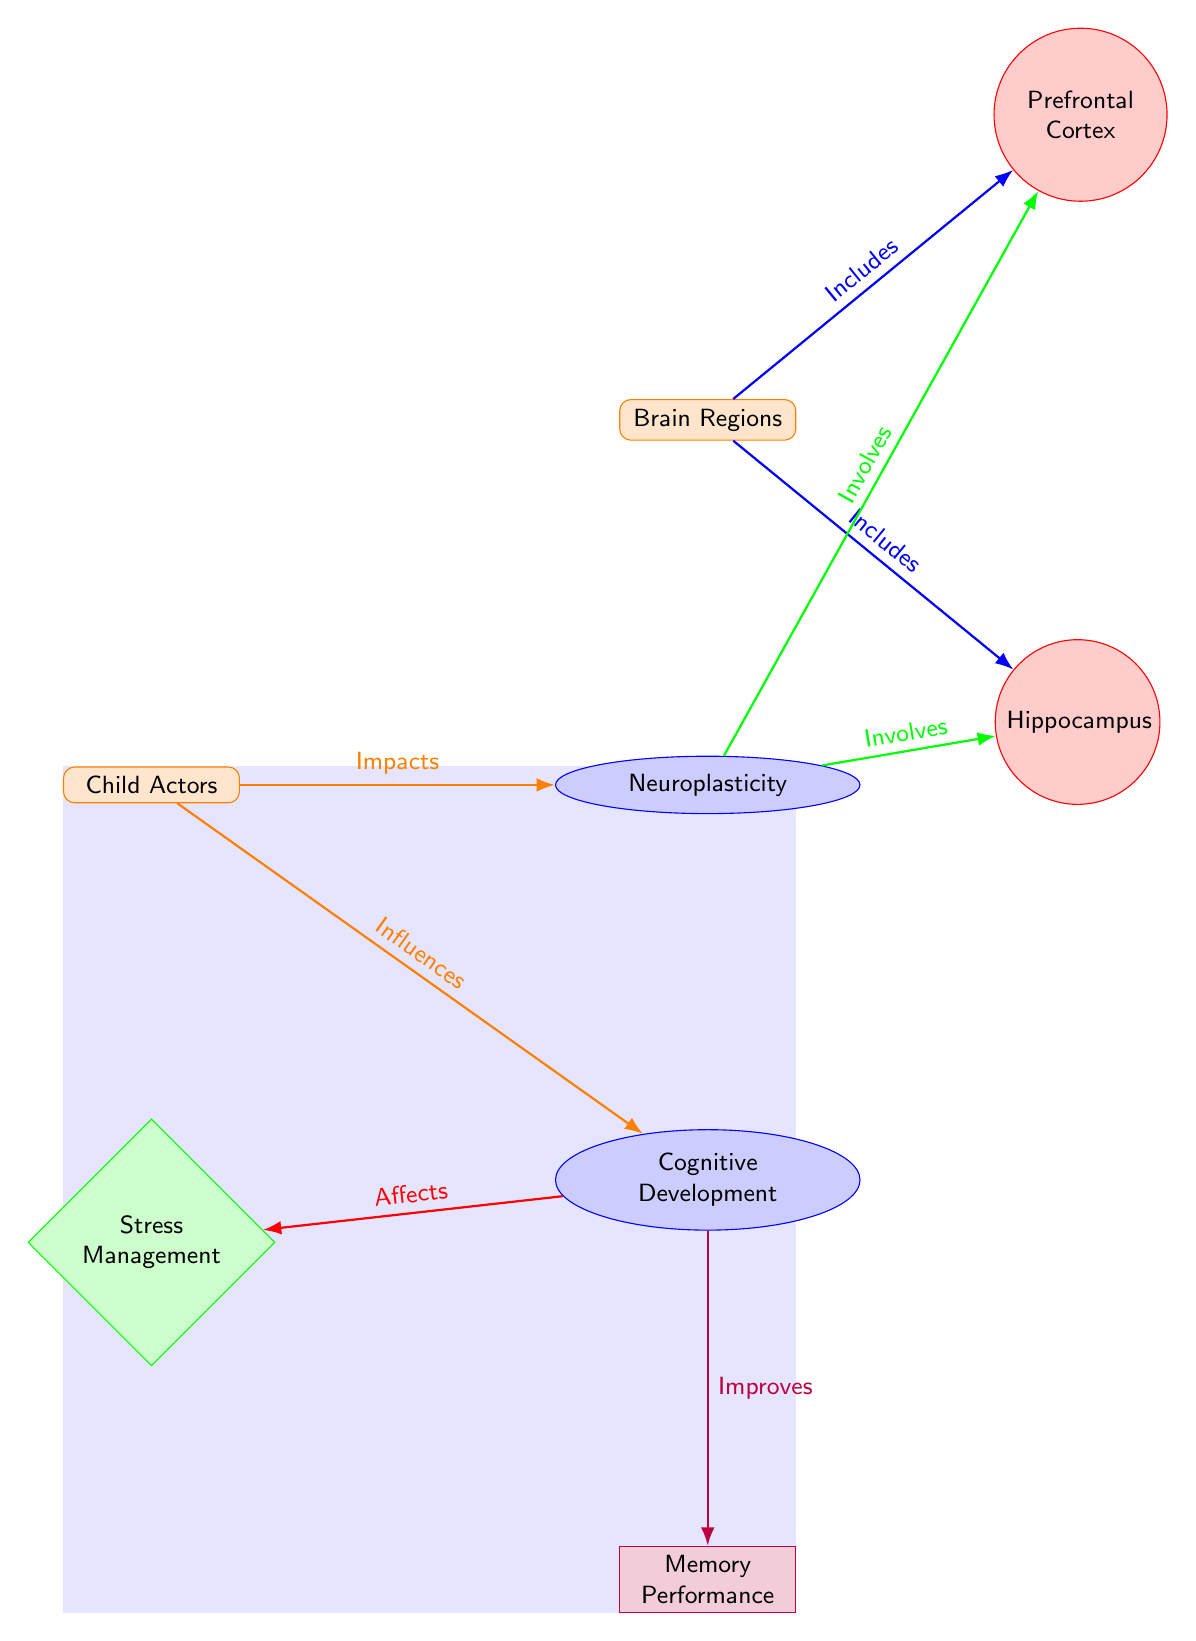What are the main categories depicted in the diagram? The diagram shows the categories "Child Actors" and "Brain Regions" as the two main categories at the top and bottom of the diagram.
Answer: Child Actors, Brain Regions How many brain parts are included in the diagram? The diagram includes two brain parts, the Prefrontal Cortex and the Hippocampus, which are represented as individual nodes connected to the Brain Regions category.
Answer: 2 What does "Neuroplasticity" involve according to the connections in the diagram? The diagram shows that Neuroplasticity involves both the Prefrontal Cortex and the Hippocampus as factors indicative of its complexity and connection to brain functions.
Answer: Prefrontal Cortex, Hippocampus Which outcome is linked to cognitive development? The diagram indicates that cognitive development improves memory performance, demonstrating a direct link between these two concepts.
Answer: Memory Performance What is the relationship between child actors and neuroplasticity? The diagram depicts that child actors impact neuroplasticity, suggesting a connection where experiences as child actors influence the brain's ability to adapt and change.
Answer: Impacts How does stress management relate to cognitive development? According to the diagram, cognitive development affects stress management, indicating a reciprocal relationship where cognitive skills can help in managing stress better.
Answer: Affects What is included in the brain regions category? The brain regions category includes the Prefrontal Cortex and Hippocampus as listed in the diagram, which represent specific areas involved in neuroplasticity and cognitive development.
Answer: Prefrontal Cortex, Hippocampus Which concepts are shown to be influencing cognitive development? The diagram demonstrates that both child actors and neuroplasticity influence cognitive development, showcasing how experiences and brain adaptability play a role.
Answer: Child Actors, Neuroplasticity What color represents scientific concepts in the diagram? The scientific concepts, including neuroplasticity and cognitive development, are represented in blue, helping to distinguish them from other types of nodes.
Answer: Blue 